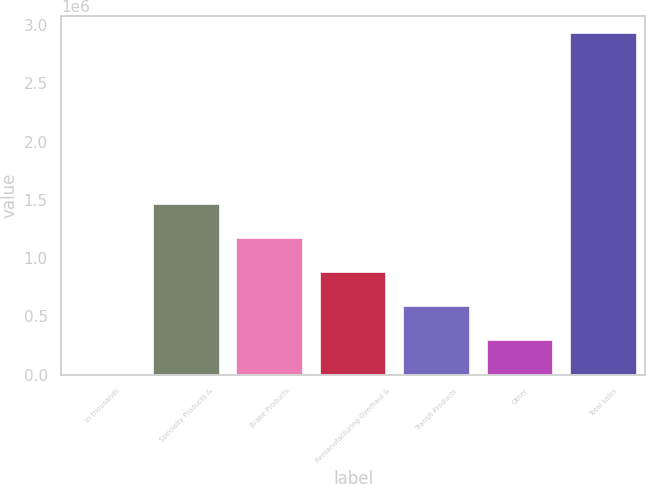Convert chart to OTSL. <chart><loc_0><loc_0><loc_500><loc_500><bar_chart><fcel>In thousands<fcel>Specialty Products &<fcel>Brake Products<fcel>Remanufacturing Overhaul &<fcel>Transit Products<fcel>Other<fcel>Total sales<nl><fcel>2016<fcel>1.4666e+06<fcel>1.17368e+06<fcel>880768<fcel>587850<fcel>294933<fcel>2.93119e+06<nl></chart> 